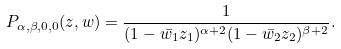<formula> <loc_0><loc_0><loc_500><loc_500>P _ { \alpha , \beta , 0 , 0 } ( z , w ) = \frac { 1 } { ( 1 - \bar { w _ { 1 } } z _ { 1 } ) ^ { \alpha + 2 } ( 1 - \bar { w _ { 2 } } z _ { 2 } ) ^ { \beta + 2 } } .</formula> 